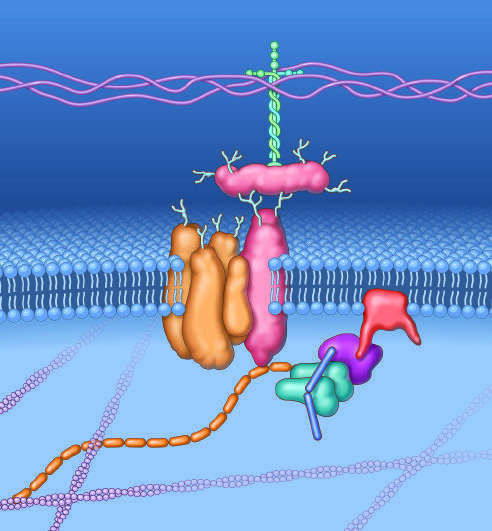does this complex of glycoproteins serve to couple the cell membrane to extracellular matrix proteins such as laminin-2 and the intracellular cytoskeleton?
Answer the question using a single word or phrase. Yes 